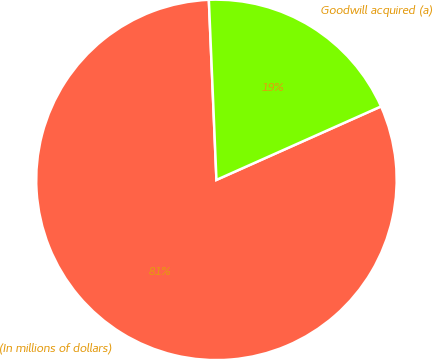Convert chart to OTSL. <chart><loc_0><loc_0><loc_500><loc_500><pie_chart><fcel>(In millions of dollars)<fcel>Goodwill acquired (a)<nl><fcel>81.01%<fcel>18.99%<nl></chart> 